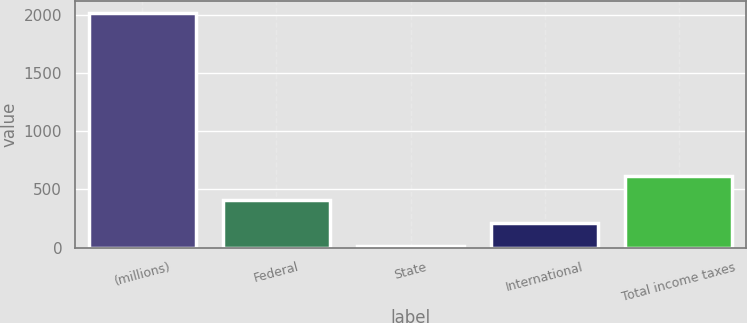Convert chart. <chart><loc_0><loc_0><loc_500><loc_500><bar_chart><fcel>(millions)<fcel>Federal<fcel>State<fcel>International<fcel>Total income taxes<nl><fcel>2014<fcel>411.84<fcel>11.3<fcel>211.57<fcel>612.11<nl></chart> 